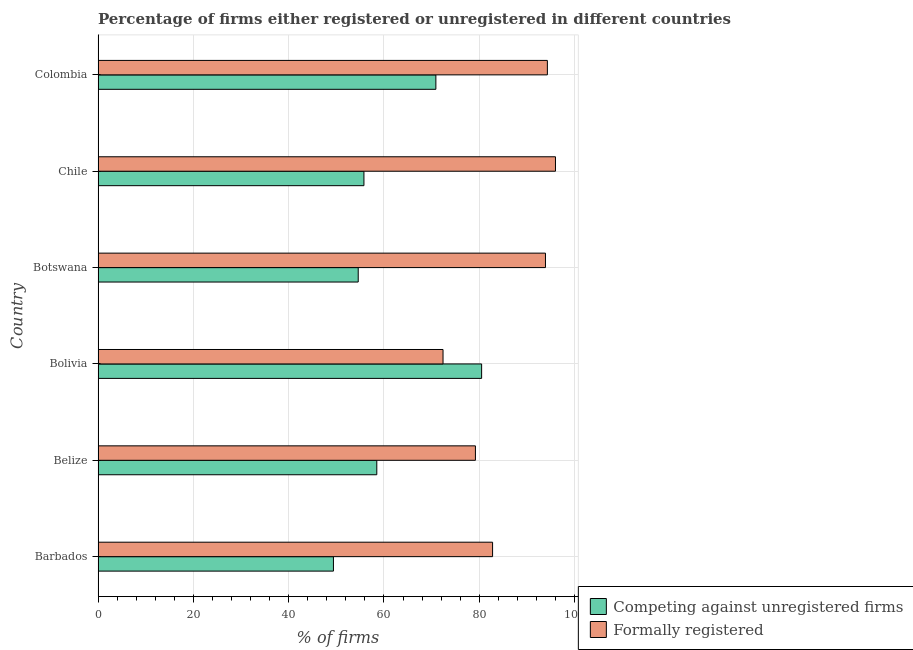How many different coloured bars are there?
Keep it short and to the point. 2. How many groups of bars are there?
Provide a short and direct response. 6. Are the number of bars on each tick of the Y-axis equal?
Your response must be concise. Yes. In how many cases, is the number of bars for a given country not equal to the number of legend labels?
Make the answer very short. 0. What is the percentage of registered firms in Barbados?
Provide a succinct answer. 49.4. Across all countries, what is the maximum percentage of registered firms?
Your answer should be compact. 80.5. Across all countries, what is the minimum percentage of registered firms?
Provide a short and direct response. 49.4. In which country was the percentage of formally registered firms minimum?
Give a very brief answer. Bolivia. What is the total percentage of formally registered firms in the graph?
Ensure brevity in your answer.  518.6. What is the difference between the percentage of registered firms in Barbados and that in Bolivia?
Make the answer very short. -31.1. What is the difference between the percentage of formally registered firms in Botswana and the percentage of registered firms in Colombia?
Offer a very short reply. 23. What is the average percentage of formally registered firms per country?
Ensure brevity in your answer.  86.43. What is the difference between the percentage of formally registered firms and percentage of registered firms in Chile?
Ensure brevity in your answer.  40.2. In how many countries, is the percentage of formally registered firms greater than 12 %?
Provide a short and direct response. 6. What is the ratio of the percentage of registered firms in Barbados to that in Bolivia?
Make the answer very short. 0.61. Is the percentage of formally registered firms in Barbados less than that in Botswana?
Provide a succinct answer. Yes. Is the difference between the percentage of registered firms in Belize and Bolivia greater than the difference between the percentage of formally registered firms in Belize and Bolivia?
Make the answer very short. No. What is the difference between the highest and the lowest percentage of formally registered firms?
Provide a succinct answer. 23.6. In how many countries, is the percentage of registered firms greater than the average percentage of registered firms taken over all countries?
Keep it short and to the point. 2. Is the sum of the percentage of formally registered firms in Bolivia and Chile greater than the maximum percentage of registered firms across all countries?
Ensure brevity in your answer.  Yes. What does the 1st bar from the top in Bolivia represents?
Give a very brief answer. Formally registered. What does the 1st bar from the bottom in Chile represents?
Keep it short and to the point. Competing against unregistered firms. How many countries are there in the graph?
Offer a terse response. 6. Are the values on the major ticks of X-axis written in scientific E-notation?
Offer a terse response. No. Does the graph contain any zero values?
Your response must be concise. No. Does the graph contain grids?
Your answer should be compact. Yes. How are the legend labels stacked?
Ensure brevity in your answer.  Vertical. What is the title of the graph?
Give a very brief answer. Percentage of firms either registered or unregistered in different countries. What is the label or title of the X-axis?
Your answer should be very brief. % of firms. What is the label or title of the Y-axis?
Make the answer very short. Country. What is the % of firms in Competing against unregistered firms in Barbados?
Provide a succinct answer. 49.4. What is the % of firms in Formally registered in Barbados?
Keep it short and to the point. 82.8. What is the % of firms of Competing against unregistered firms in Belize?
Your answer should be very brief. 58.5. What is the % of firms in Formally registered in Belize?
Keep it short and to the point. 79.2. What is the % of firms of Competing against unregistered firms in Bolivia?
Keep it short and to the point. 80.5. What is the % of firms in Formally registered in Bolivia?
Make the answer very short. 72.4. What is the % of firms of Competing against unregistered firms in Botswana?
Provide a short and direct response. 54.6. What is the % of firms of Formally registered in Botswana?
Offer a terse response. 93.9. What is the % of firms in Competing against unregistered firms in Chile?
Keep it short and to the point. 55.8. What is the % of firms in Formally registered in Chile?
Provide a succinct answer. 96. What is the % of firms in Competing against unregistered firms in Colombia?
Keep it short and to the point. 70.9. What is the % of firms in Formally registered in Colombia?
Make the answer very short. 94.3. Across all countries, what is the maximum % of firms of Competing against unregistered firms?
Your response must be concise. 80.5. Across all countries, what is the maximum % of firms in Formally registered?
Offer a very short reply. 96. Across all countries, what is the minimum % of firms in Competing against unregistered firms?
Your response must be concise. 49.4. Across all countries, what is the minimum % of firms of Formally registered?
Ensure brevity in your answer.  72.4. What is the total % of firms in Competing against unregistered firms in the graph?
Provide a short and direct response. 369.7. What is the total % of firms of Formally registered in the graph?
Offer a very short reply. 518.6. What is the difference between the % of firms in Competing against unregistered firms in Barbados and that in Belize?
Make the answer very short. -9.1. What is the difference between the % of firms of Formally registered in Barbados and that in Belize?
Provide a succinct answer. 3.6. What is the difference between the % of firms of Competing against unregistered firms in Barbados and that in Bolivia?
Your answer should be very brief. -31.1. What is the difference between the % of firms of Formally registered in Barbados and that in Bolivia?
Provide a succinct answer. 10.4. What is the difference between the % of firms in Competing against unregistered firms in Barbados and that in Colombia?
Your answer should be compact. -21.5. What is the difference between the % of firms of Formally registered in Barbados and that in Colombia?
Provide a succinct answer. -11.5. What is the difference between the % of firms of Formally registered in Belize and that in Bolivia?
Offer a terse response. 6.8. What is the difference between the % of firms in Formally registered in Belize and that in Botswana?
Offer a very short reply. -14.7. What is the difference between the % of firms of Competing against unregistered firms in Belize and that in Chile?
Your answer should be compact. 2.7. What is the difference between the % of firms in Formally registered in Belize and that in Chile?
Make the answer very short. -16.8. What is the difference between the % of firms in Formally registered in Belize and that in Colombia?
Provide a succinct answer. -15.1. What is the difference between the % of firms in Competing against unregistered firms in Bolivia and that in Botswana?
Your response must be concise. 25.9. What is the difference between the % of firms of Formally registered in Bolivia and that in Botswana?
Your answer should be very brief. -21.5. What is the difference between the % of firms of Competing against unregistered firms in Bolivia and that in Chile?
Make the answer very short. 24.7. What is the difference between the % of firms of Formally registered in Bolivia and that in Chile?
Ensure brevity in your answer.  -23.6. What is the difference between the % of firms of Formally registered in Bolivia and that in Colombia?
Provide a succinct answer. -21.9. What is the difference between the % of firms in Competing against unregistered firms in Botswana and that in Colombia?
Your answer should be compact. -16.3. What is the difference between the % of firms in Formally registered in Botswana and that in Colombia?
Provide a succinct answer. -0.4. What is the difference between the % of firms of Competing against unregistered firms in Chile and that in Colombia?
Provide a succinct answer. -15.1. What is the difference between the % of firms in Competing against unregistered firms in Barbados and the % of firms in Formally registered in Belize?
Your answer should be compact. -29.8. What is the difference between the % of firms in Competing against unregistered firms in Barbados and the % of firms in Formally registered in Bolivia?
Give a very brief answer. -23. What is the difference between the % of firms of Competing against unregistered firms in Barbados and the % of firms of Formally registered in Botswana?
Your answer should be very brief. -44.5. What is the difference between the % of firms of Competing against unregistered firms in Barbados and the % of firms of Formally registered in Chile?
Ensure brevity in your answer.  -46.6. What is the difference between the % of firms in Competing against unregistered firms in Barbados and the % of firms in Formally registered in Colombia?
Give a very brief answer. -44.9. What is the difference between the % of firms of Competing against unregistered firms in Belize and the % of firms of Formally registered in Bolivia?
Give a very brief answer. -13.9. What is the difference between the % of firms in Competing against unregistered firms in Belize and the % of firms in Formally registered in Botswana?
Provide a short and direct response. -35.4. What is the difference between the % of firms of Competing against unregistered firms in Belize and the % of firms of Formally registered in Chile?
Provide a short and direct response. -37.5. What is the difference between the % of firms in Competing against unregistered firms in Belize and the % of firms in Formally registered in Colombia?
Give a very brief answer. -35.8. What is the difference between the % of firms in Competing against unregistered firms in Bolivia and the % of firms in Formally registered in Botswana?
Provide a short and direct response. -13.4. What is the difference between the % of firms of Competing against unregistered firms in Bolivia and the % of firms of Formally registered in Chile?
Offer a terse response. -15.5. What is the difference between the % of firms in Competing against unregistered firms in Bolivia and the % of firms in Formally registered in Colombia?
Ensure brevity in your answer.  -13.8. What is the difference between the % of firms in Competing against unregistered firms in Botswana and the % of firms in Formally registered in Chile?
Your answer should be very brief. -41.4. What is the difference between the % of firms of Competing against unregistered firms in Botswana and the % of firms of Formally registered in Colombia?
Ensure brevity in your answer.  -39.7. What is the difference between the % of firms in Competing against unregistered firms in Chile and the % of firms in Formally registered in Colombia?
Provide a succinct answer. -38.5. What is the average % of firms of Competing against unregistered firms per country?
Keep it short and to the point. 61.62. What is the average % of firms in Formally registered per country?
Make the answer very short. 86.43. What is the difference between the % of firms of Competing against unregistered firms and % of firms of Formally registered in Barbados?
Make the answer very short. -33.4. What is the difference between the % of firms of Competing against unregistered firms and % of firms of Formally registered in Belize?
Your answer should be very brief. -20.7. What is the difference between the % of firms in Competing against unregistered firms and % of firms in Formally registered in Bolivia?
Your response must be concise. 8.1. What is the difference between the % of firms in Competing against unregistered firms and % of firms in Formally registered in Botswana?
Give a very brief answer. -39.3. What is the difference between the % of firms in Competing against unregistered firms and % of firms in Formally registered in Chile?
Make the answer very short. -40.2. What is the difference between the % of firms in Competing against unregistered firms and % of firms in Formally registered in Colombia?
Make the answer very short. -23.4. What is the ratio of the % of firms of Competing against unregistered firms in Barbados to that in Belize?
Ensure brevity in your answer.  0.84. What is the ratio of the % of firms in Formally registered in Barbados to that in Belize?
Your answer should be compact. 1.05. What is the ratio of the % of firms of Competing against unregistered firms in Barbados to that in Bolivia?
Your answer should be very brief. 0.61. What is the ratio of the % of firms of Formally registered in Barbados to that in Bolivia?
Keep it short and to the point. 1.14. What is the ratio of the % of firms in Competing against unregistered firms in Barbados to that in Botswana?
Your response must be concise. 0.9. What is the ratio of the % of firms of Formally registered in Barbados to that in Botswana?
Provide a succinct answer. 0.88. What is the ratio of the % of firms of Competing against unregistered firms in Barbados to that in Chile?
Your answer should be compact. 0.89. What is the ratio of the % of firms in Formally registered in Barbados to that in Chile?
Ensure brevity in your answer.  0.86. What is the ratio of the % of firms in Competing against unregistered firms in Barbados to that in Colombia?
Provide a succinct answer. 0.7. What is the ratio of the % of firms of Formally registered in Barbados to that in Colombia?
Give a very brief answer. 0.88. What is the ratio of the % of firms of Competing against unregistered firms in Belize to that in Bolivia?
Make the answer very short. 0.73. What is the ratio of the % of firms of Formally registered in Belize to that in Bolivia?
Provide a short and direct response. 1.09. What is the ratio of the % of firms of Competing against unregistered firms in Belize to that in Botswana?
Give a very brief answer. 1.07. What is the ratio of the % of firms of Formally registered in Belize to that in Botswana?
Give a very brief answer. 0.84. What is the ratio of the % of firms in Competing against unregistered firms in Belize to that in Chile?
Give a very brief answer. 1.05. What is the ratio of the % of firms in Formally registered in Belize to that in Chile?
Give a very brief answer. 0.82. What is the ratio of the % of firms of Competing against unregistered firms in Belize to that in Colombia?
Give a very brief answer. 0.83. What is the ratio of the % of firms of Formally registered in Belize to that in Colombia?
Provide a succinct answer. 0.84. What is the ratio of the % of firms of Competing against unregistered firms in Bolivia to that in Botswana?
Offer a very short reply. 1.47. What is the ratio of the % of firms in Formally registered in Bolivia to that in Botswana?
Keep it short and to the point. 0.77. What is the ratio of the % of firms in Competing against unregistered firms in Bolivia to that in Chile?
Offer a very short reply. 1.44. What is the ratio of the % of firms of Formally registered in Bolivia to that in Chile?
Offer a terse response. 0.75. What is the ratio of the % of firms of Competing against unregistered firms in Bolivia to that in Colombia?
Give a very brief answer. 1.14. What is the ratio of the % of firms in Formally registered in Bolivia to that in Colombia?
Offer a terse response. 0.77. What is the ratio of the % of firms in Competing against unregistered firms in Botswana to that in Chile?
Provide a short and direct response. 0.98. What is the ratio of the % of firms of Formally registered in Botswana to that in Chile?
Keep it short and to the point. 0.98. What is the ratio of the % of firms of Competing against unregistered firms in Botswana to that in Colombia?
Give a very brief answer. 0.77. What is the ratio of the % of firms of Competing against unregistered firms in Chile to that in Colombia?
Ensure brevity in your answer.  0.79. What is the ratio of the % of firms of Formally registered in Chile to that in Colombia?
Offer a very short reply. 1.02. What is the difference between the highest and the lowest % of firms of Competing against unregistered firms?
Provide a short and direct response. 31.1. What is the difference between the highest and the lowest % of firms in Formally registered?
Give a very brief answer. 23.6. 